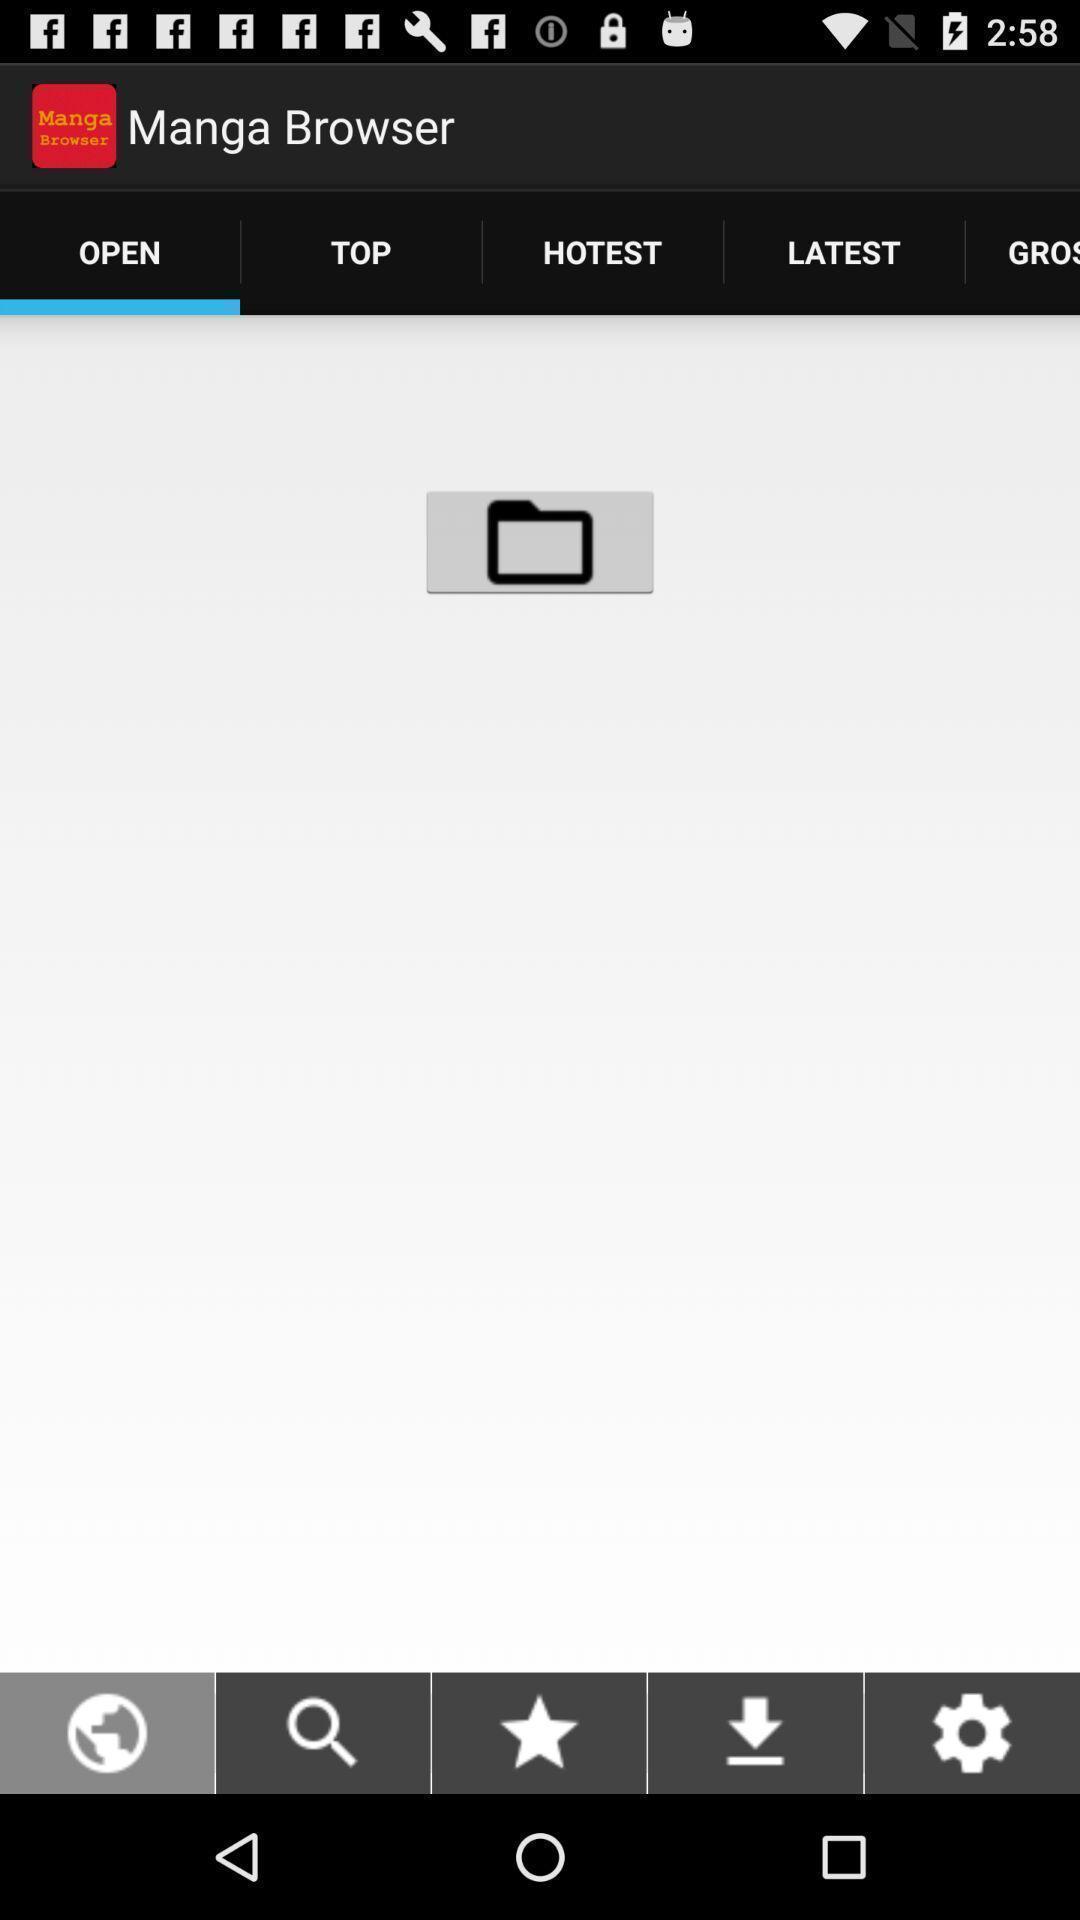What is the overall content of this screenshot? Screen shows multiple options. 